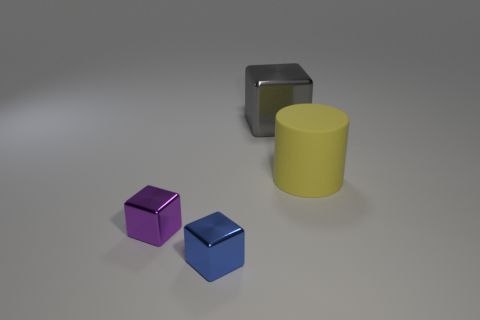Do the large matte thing and the object behind the yellow cylinder have the same color? no 